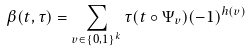Convert formula to latex. <formula><loc_0><loc_0><loc_500><loc_500>\beta ( t , \tau ) = \sum _ { v \in \{ 0 , 1 \} ^ { k } } \tau ( t \circ \Psi _ { v } ) ( - 1 ) ^ { h ( v ) }</formula> 